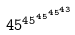<formula> <loc_0><loc_0><loc_500><loc_500>4 5 ^ { 4 5 ^ { 4 5 ^ { 4 5 ^ { 4 3 } } } }</formula> 